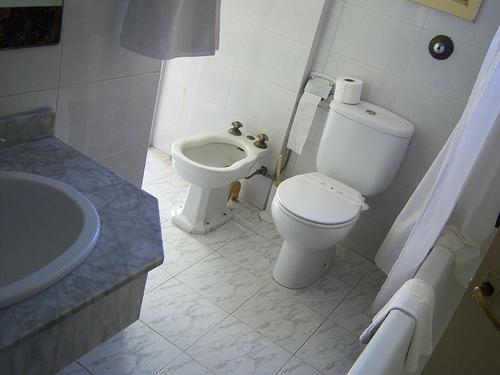Why is the toilet paper on top of the toilet? extra 